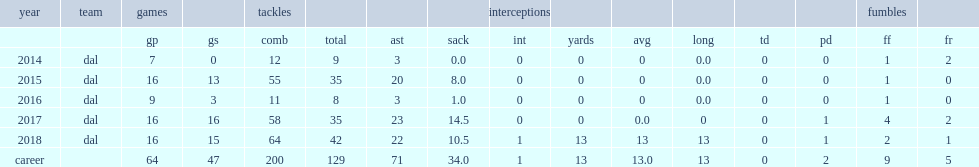When did lawrence have 14.5 sacks? 2017.0. Could you help me parse every detail presented in this table? {'header': ['year', 'team', 'games', '', 'tackles', '', '', '', 'interceptions', '', '', '', '', '', 'fumbles', ''], 'rows': [['', '', 'gp', 'gs', 'comb', 'total', 'ast', 'sack', 'int', 'yards', 'avg', 'long', 'td', 'pd', 'ff', 'fr'], ['2014', 'dal', '7', '0', '12', '9', '3', '0.0', '0', '0', '0', '0.0', '0', '0', '1', '2'], ['2015', 'dal', '16', '13', '55', '35', '20', '8.0', '0', '0', '0', '0.0', '0', '0', '1', '0'], ['2016', 'dal', '9', '3', '11', '8', '3', '1.0', '0', '0', '0', '0.0', '0', '0', '1', '0'], ['2017', 'dal', '16', '16', '58', '35', '23', '14.5', '0', '0', '0.0', '0', '0', '1', '4', '2'], ['2018', 'dal', '16', '15', '64', '42', '22', '10.5', '1', '13', '13', '13', '0', '1', '2', '1'], ['career', '', '64', '47', '200', '129', '71', '34.0', '1', '13', '13.0', '13', '0', '2', '9', '5']]} 